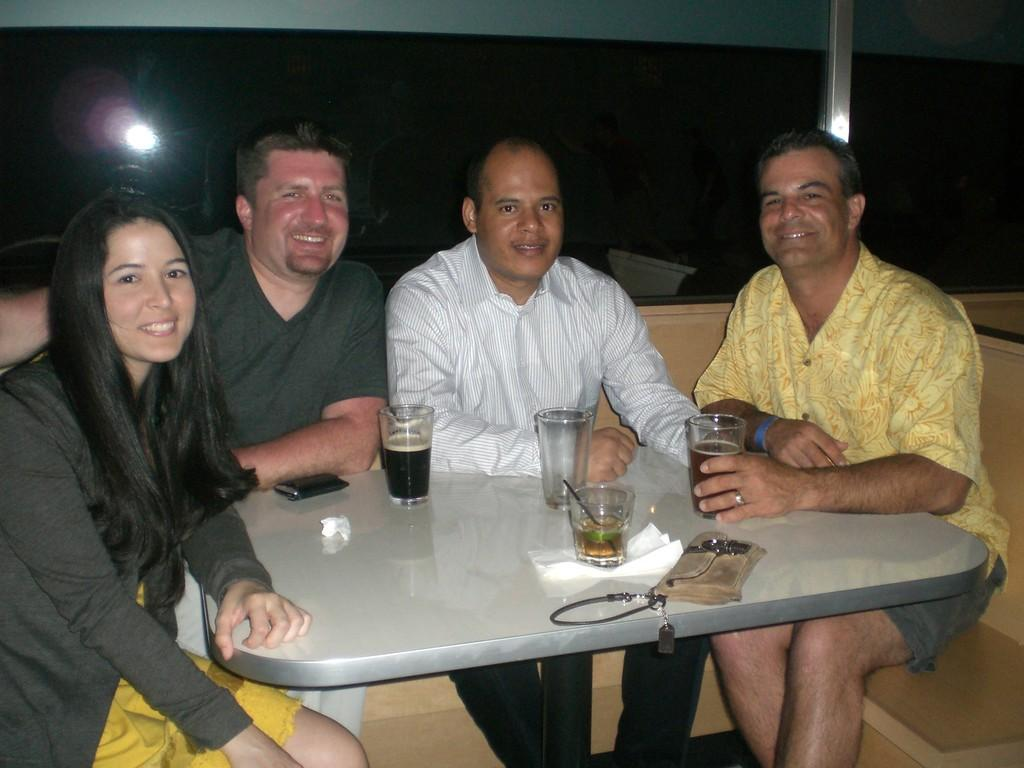What is the main subject of the image? The main subject of the image is a group of men and women. Where are the people in the image sitting? The people are sitting on a sofa. How is the sofa arranged in the image? The sofa is arranged around a table. What can be seen on the table in the image? There are wine glasses on the table. Is there a river flowing through the room in the image? No, there is no river present in the image. 